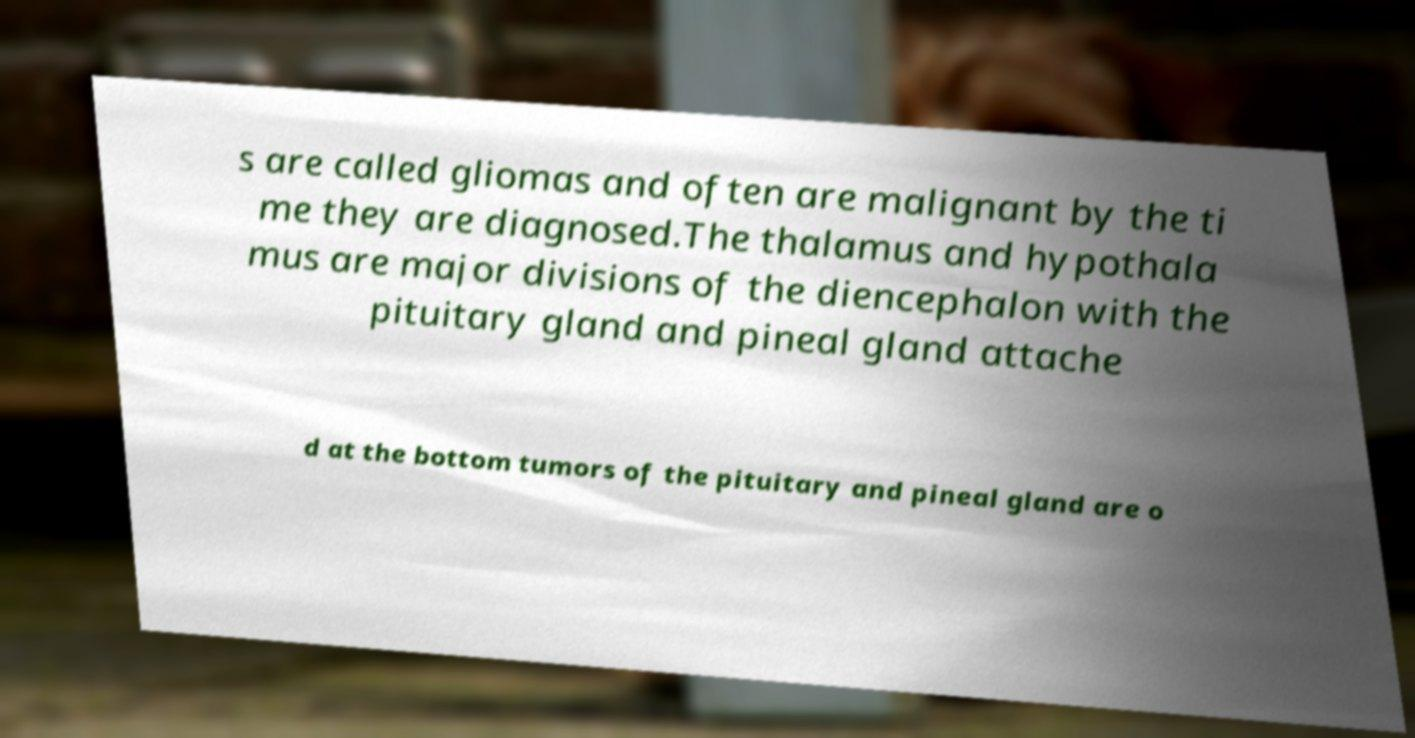I need the written content from this picture converted into text. Can you do that? s are called gliomas and often are malignant by the ti me they are diagnosed.The thalamus and hypothala mus are major divisions of the diencephalon with the pituitary gland and pineal gland attache d at the bottom tumors of the pituitary and pineal gland are o 